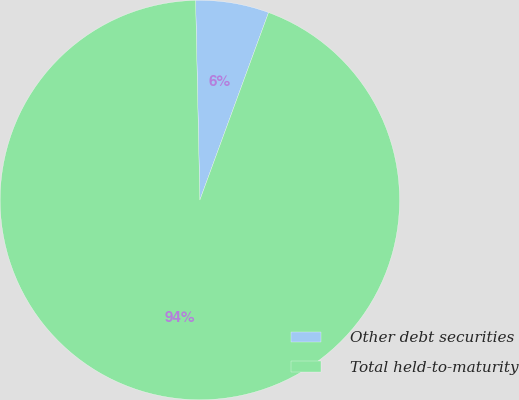Convert chart. <chart><loc_0><loc_0><loc_500><loc_500><pie_chart><fcel>Other debt securities<fcel>Total held-to-maturity<nl><fcel>5.93%<fcel>94.07%<nl></chart> 